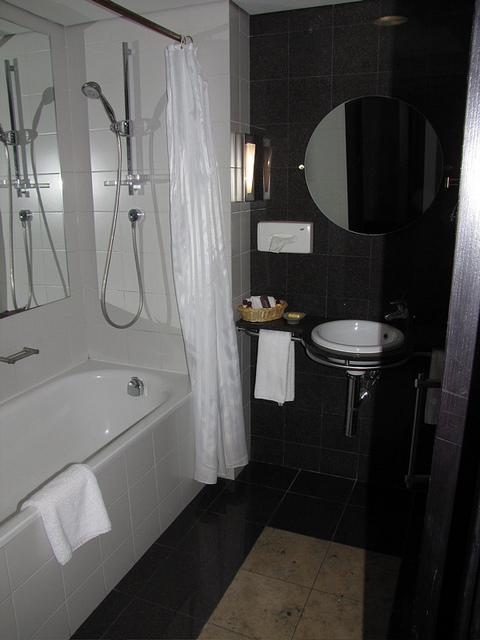How many mirrors are in the bathroom?
Give a very brief answer. 2. How many trains are there?
Give a very brief answer. 0. How many faucets does the sink have?
Give a very brief answer. 1. How many zebras are there?
Give a very brief answer. 0. 